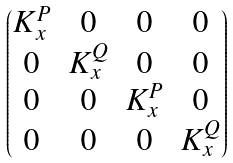Convert formula to latex. <formula><loc_0><loc_0><loc_500><loc_500>\begin{pmatrix} K ^ { P } _ { x } & 0 & 0 & 0 \\ 0 & K ^ { Q } _ { x } & 0 & 0 \\ 0 & 0 & K ^ { P } _ { x } & 0 \\ 0 & 0 & 0 & K ^ { Q } _ { x } \end{pmatrix}</formula> 